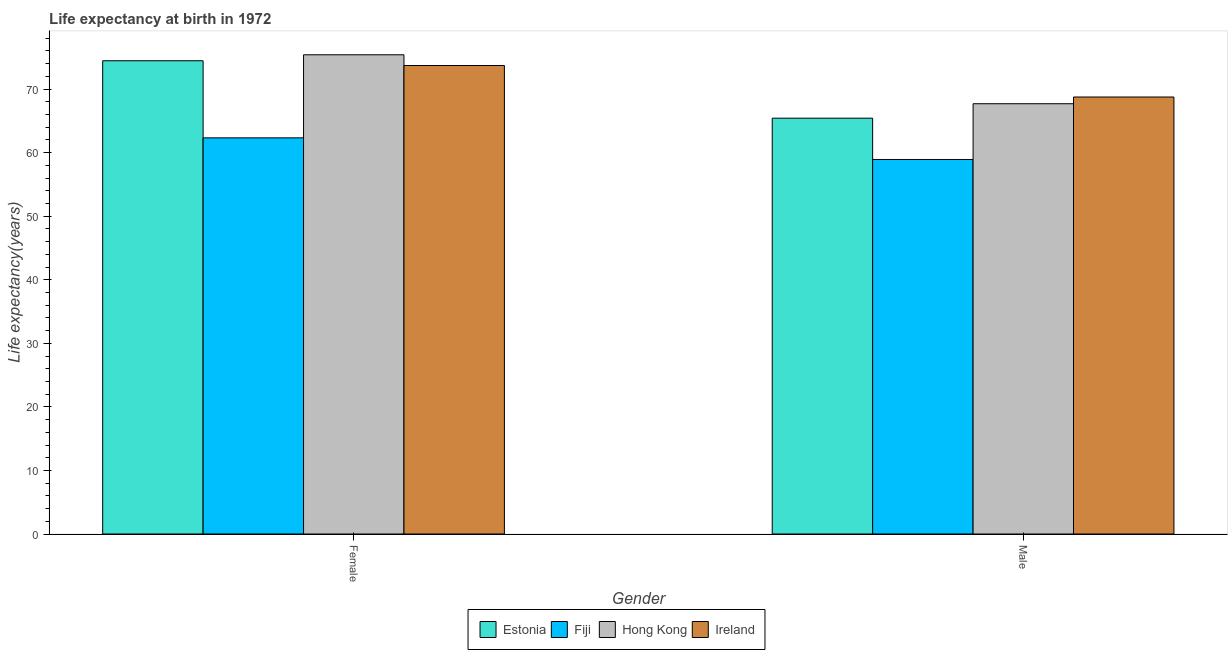How many groups of bars are there?
Offer a very short reply. 2. Are the number of bars per tick equal to the number of legend labels?
Your response must be concise. Yes. Are the number of bars on each tick of the X-axis equal?
Your answer should be very brief. Yes. How many bars are there on the 1st tick from the left?
Provide a short and direct response. 4. What is the life expectancy(female) in Ireland?
Your answer should be compact. 73.71. Across all countries, what is the maximum life expectancy(female)?
Your answer should be very brief. 75.4. Across all countries, what is the minimum life expectancy(male)?
Your response must be concise. 58.93. In which country was the life expectancy(female) maximum?
Ensure brevity in your answer.  Hong Kong. In which country was the life expectancy(male) minimum?
Offer a terse response. Fiji. What is the total life expectancy(male) in the graph?
Your answer should be compact. 260.81. What is the difference between the life expectancy(female) in Hong Kong and that in Fiji?
Your answer should be very brief. 13.07. What is the difference between the life expectancy(female) in Ireland and the life expectancy(male) in Fiji?
Your answer should be compact. 14.78. What is the average life expectancy(female) per country?
Your answer should be very brief. 71.48. What is the difference between the life expectancy(female) and life expectancy(male) in Ireland?
Keep it short and to the point. 4.95. What is the ratio of the life expectancy(male) in Hong Kong to that in Ireland?
Ensure brevity in your answer.  0.98. In how many countries, is the life expectancy(male) greater than the average life expectancy(male) taken over all countries?
Provide a short and direct response. 3. What does the 1st bar from the left in Male represents?
Give a very brief answer. Estonia. What does the 2nd bar from the right in Female represents?
Provide a succinct answer. Hong Kong. How many bars are there?
Provide a succinct answer. 8. Are all the bars in the graph horizontal?
Provide a succinct answer. No. How many countries are there in the graph?
Your answer should be compact. 4. What is the difference between two consecutive major ticks on the Y-axis?
Give a very brief answer. 10. Where does the legend appear in the graph?
Provide a short and direct response. Bottom center. What is the title of the graph?
Make the answer very short. Life expectancy at birth in 1972. Does "Cyprus" appear as one of the legend labels in the graph?
Keep it short and to the point. No. What is the label or title of the X-axis?
Ensure brevity in your answer.  Gender. What is the label or title of the Y-axis?
Give a very brief answer. Life expectancy(years). What is the Life expectancy(years) of Estonia in Female?
Your answer should be compact. 74.46. What is the Life expectancy(years) in Fiji in Female?
Provide a short and direct response. 62.33. What is the Life expectancy(years) in Hong Kong in Female?
Ensure brevity in your answer.  75.4. What is the Life expectancy(years) in Ireland in Female?
Your response must be concise. 73.71. What is the Life expectancy(years) in Estonia in Male?
Give a very brief answer. 65.43. What is the Life expectancy(years) in Fiji in Male?
Your answer should be compact. 58.93. What is the Life expectancy(years) in Hong Kong in Male?
Provide a short and direct response. 67.7. What is the Life expectancy(years) in Ireland in Male?
Keep it short and to the point. 68.76. Across all Gender, what is the maximum Life expectancy(years) in Estonia?
Give a very brief answer. 74.46. Across all Gender, what is the maximum Life expectancy(years) in Fiji?
Provide a succinct answer. 62.33. Across all Gender, what is the maximum Life expectancy(years) of Hong Kong?
Your answer should be compact. 75.4. Across all Gender, what is the maximum Life expectancy(years) in Ireland?
Provide a short and direct response. 73.71. Across all Gender, what is the minimum Life expectancy(years) of Estonia?
Provide a short and direct response. 65.43. Across all Gender, what is the minimum Life expectancy(years) of Fiji?
Your answer should be compact. 58.93. Across all Gender, what is the minimum Life expectancy(years) in Hong Kong?
Keep it short and to the point. 67.7. Across all Gender, what is the minimum Life expectancy(years) of Ireland?
Ensure brevity in your answer.  68.76. What is the total Life expectancy(years) in Estonia in the graph?
Provide a short and direct response. 139.89. What is the total Life expectancy(years) in Fiji in the graph?
Ensure brevity in your answer.  121.26. What is the total Life expectancy(years) of Hong Kong in the graph?
Give a very brief answer. 143.1. What is the total Life expectancy(years) in Ireland in the graph?
Your answer should be very brief. 142.47. What is the difference between the Life expectancy(years) in Estonia in Female and that in Male?
Keep it short and to the point. 9.04. What is the difference between the Life expectancy(years) in Fiji in Female and that in Male?
Your response must be concise. 3.4. What is the difference between the Life expectancy(years) in Hong Kong in Female and that in Male?
Offer a terse response. 7.7. What is the difference between the Life expectancy(years) in Ireland in Female and that in Male?
Your response must be concise. 4.95. What is the difference between the Life expectancy(years) of Estonia in Female and the Life expectancy(years) of Fiji in Male?
Provide a short and direct response. 15.53. What is the difference between the Life expectancy(years) in Estonia in Female and the Life expectancy(years) in Hong Kong in Male?
Your answer should be compact. 6.76. What is the difference between the Life expectancy(years) in Estonia in Female and the Life expectancy(years) in Ireland in Male?
Offer a very short reply. 5.7. What is the difference between the Life expectancy(years) in Fiji in Female and the Life expectancy(years) in Hong Kong in Male?
Offer a terse response. -5.37. What is the difference between the Life expectancy(years) in Fiji in Female and the Life expectancy(years) in Ireland in Male?
Make the answer very short. -6.43. What is the difference between the Life expectancy(years) in Hong Kong in Female and the Life expectancy(years) in Ireland in Male?
Offer a terse response. 6.64. What is the average Life expectancy(years) of Estonia per Gender?
Make the answer very short. 69.94. What is the average Life expectancy(years) of Fiji per Gender?
Provide a succinct answer. 60.63. What is the average Life expectancy(years) in Hong Kong per Gender?
Provide a succinct answer. 71.55. What is the average Life expectancy(years) in Ireland per Gender?
Offer a very short reply. 71.23. What is the difference between the Life expectancy(years) of Estonia and Life expectancy(years) of Fiji in Female?
Offer a very short reply. 12.13. What is the difference between the Life expectancy(years) of Estonia and Life expectancy(years) of Hong Kong in Female?
Your answer should be very brief. -0.94. What is the difference between the Life expectancy(years) in Estonia and Life expectancy(years) in Ireland in Female?
Your answer should be very brief. 0.75. What is the difference between the Life expectancy(years) in Fiji and Life expectancy(years) in Hong Kong in Female?
Your answer should be very brief. -13.07. What is the difference between the Life expectancy(years) of Fiji and Life expectancy(years) of Ireland in Female?
Your response must be concise. -11.38. What is the difference between the Life expectancy(years) in Hong Kong and Life expectancy(years) in Ireland in Female?
Make the answer very short. 1.69. What is the difference between the Life expectancy(years) in Estonia and Life expectancy(years) in Fiji in Male?
Your response must be concise. 6.5. What is the difference between the Life expectancy(years) in Estonia and Life expectancy(years) in Hong Kong in Male?
Your response must be concise. -2.27. What is the difference between the Life expectancy(years) of Estonia and Life expectancy(years) of Ireland in Male?
Provide a succinct answer. -3.33. What is the difference between the Life expectancy(years) in Fiji and Life expectancy(years) in Hong Kong in Male?
Give a very brief answer. -8.77. What is the difference between the Life expectancy(years) of Fiji and Life expectancy(years) of Ireland in Male?
Keep it short and to the point. -9.83. What is the difference between the Life expectancy(years) of Hong Kong and Life expectancy(years) of Ireland in Male?
Offer a very short reply. -1.06. What is the ratio of the Life expectancy(years) in Estonia in Female to that in Male?
Give a very brief answer. 1.14. What is the ratio of the Life expectancy(years) of Fiji in Female to that in Male?
Offer a terse response. 1.06. What is the ratio of the Life expectancy(years) of Hong Kong in Female to that in Male?
Offer a terse response. 1.11. What is the ratio of the Life expectancy(years) of Ireland in Female to that in Male?
Make the answer very short. 1.07. What is the difference between the highest and the second highest Life expectancy(years) of Estonia?
Keep it short and to the point. 9.04. What is the difference between the highest and the second highest Life expectancy(years) in Fiji?
Provide a short and direct response. 3.4. What is the difference between the highest and the second highest Life expectancy(years) of Ireland?
Your response must be concise. 4.95. What is the difference between the highest and the lowest Life expectancy(years) in Estonia?
Your response must be concise. 9.04. What is the difference between the highest and the lowest Life expectancy(years) of Fiji?
Provide a succinct answer. 3.4. What is the difference between the highest and the lowest Life expectancy(years) in Hong Kong?
Offer a very short reply. 7.7. What is the difference between the highest and the lowest Life expectancy(years) of Ireland?
Ensure brevity in your answer.  4.95. 